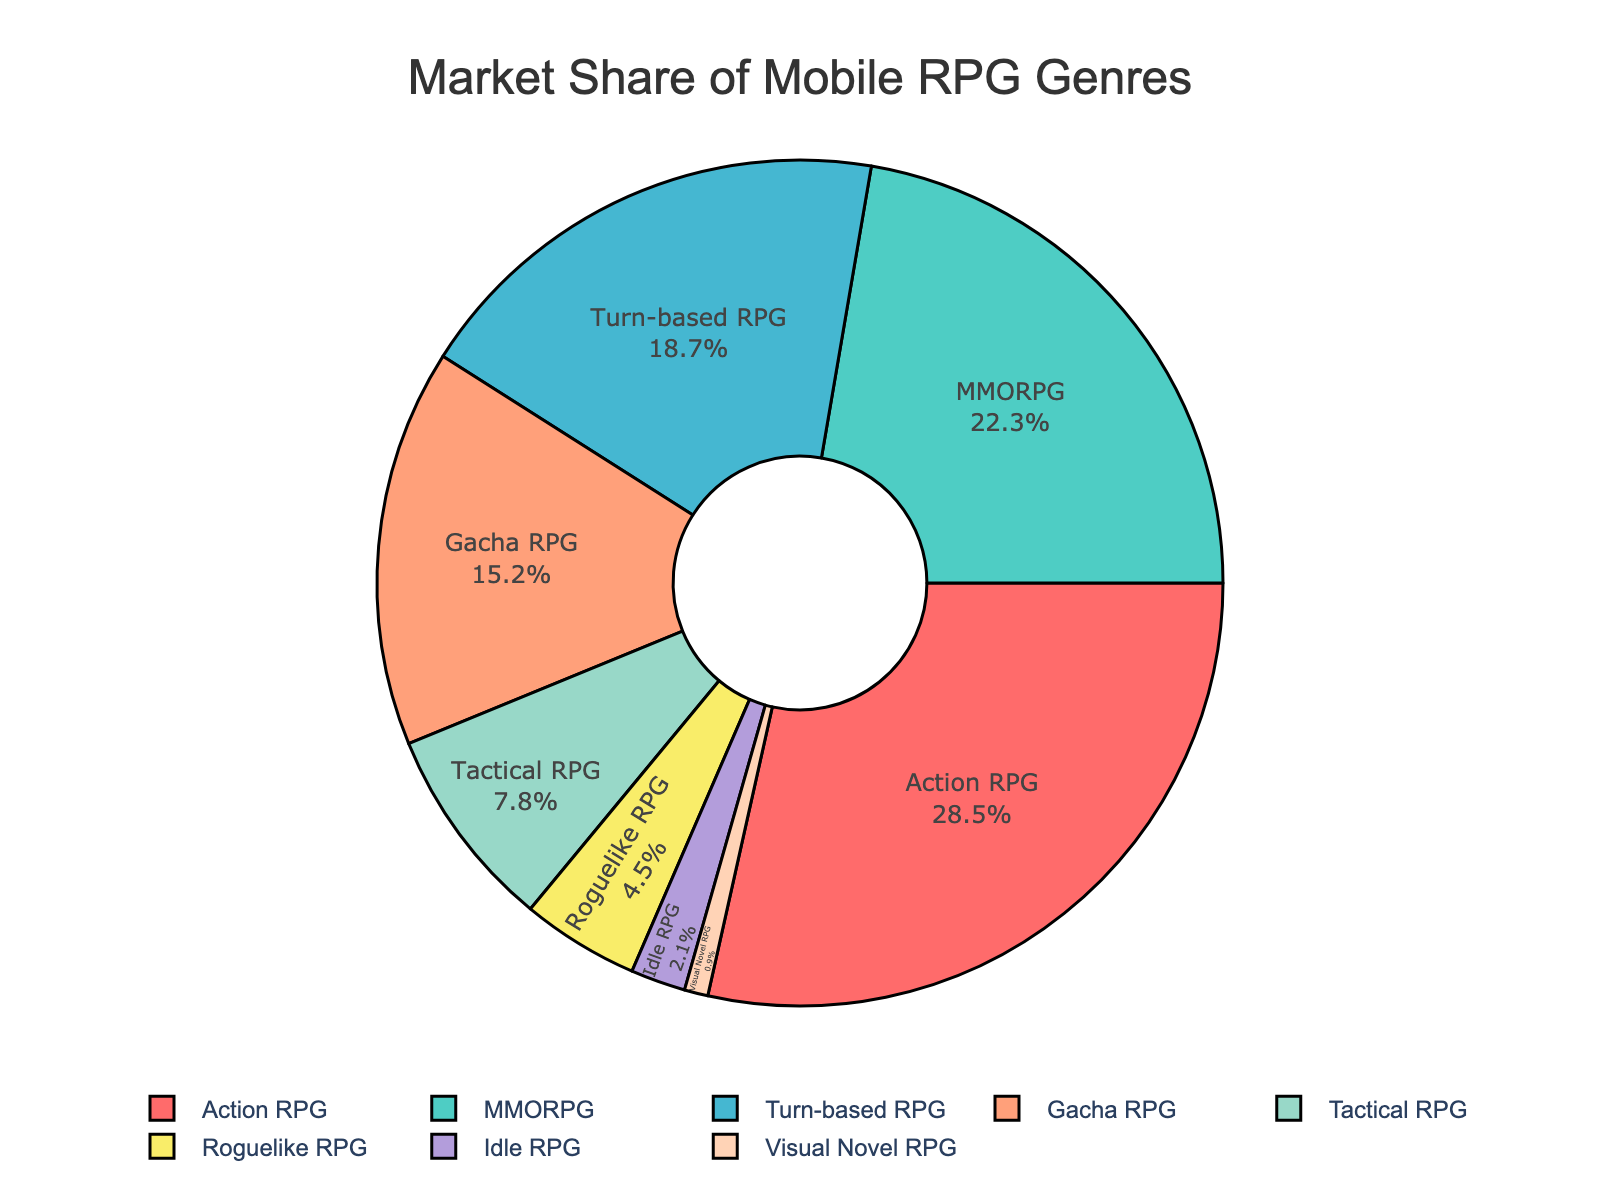What genre has the largest market share? The figure shows that the Action RPG genre has the largest slice of the pie chart, corresponding to a market share of 28.5%.
Answer: Action RPG Which genre has the smallest market share? The figure displays the smallest slice corresponding to Visual Novel RPG, which has a market share of 0.9%.
Answer: Visual Novel RPG How much larger is the market share of Action RPG compared to Idle RPG? Action RPG has a market share of 28.5%. Idle RPG has a market share of 2.1%. The difference is 28.5% - 2.1% = 26.4%.
Answer: 26.4% What is the combined market share of Turn-based RPG and Gacha RPG? The market share of Turn-based RPG is 18.7% and Gacha RPG is 15.2%. Their combined market share is 18.7% + 15.2% = 33.9%.
Answer: 33.9% Which genres have a market share greater than 20%? According to the figure, Action RPG has a market share of 28.5% and MMORPG has a market share of 22.3%, both of which are greater than 20%.
Answer: Action RPG, MMORPG What is the average market share of Tactical RPG, Roguelike RPG, and Idle RPG? The market shares are 7.8% (Tactical RPG), 4.5% (Roguelike RPG), and 2.1% (Idle RPG). The sum is 7.8 + 4.5 + 2.1 = 14.4. The average is 14.4 / 3 = 4.8.
Answer: 4.8% Which genre in the pie chart is represented with the blue color slice? The blue color slice in the pie chart corresponds to the Gacha RPG genre, which has a market share of 15.2%.
Answer: Gacha RPG What is the difference in market share between the highest and lowest represented genres? The highest market share is held by Action RPG with 28.5%, and the lowest by Visual Novel RPG with 0.9%. The difference is 28.5% - 0.9% = 27.6%.
Answer: 27.6% Which genre segment is closest to one-fourth of the total market share? One-fourth of 100% is 25%. Action RPG is the closest with a market share of 28.5%.
Answer: Action RPG 